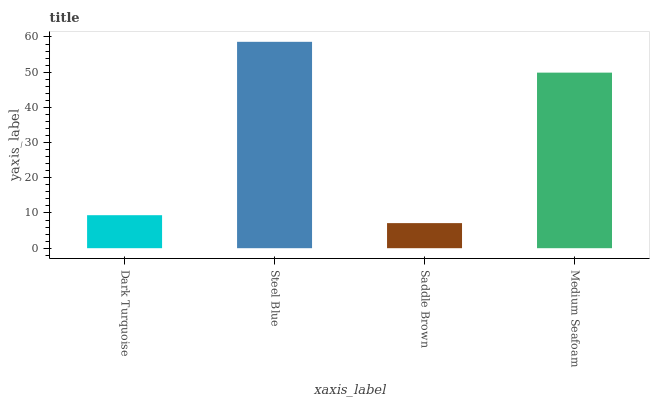Is Saddle Brown the minimum?
Answer yes or no. Yes. Is Steel Blue the maximum?
Answer yes or no. Yes. Is Steel Blue the minimum?
Answer yes or no. No. Is Saddle Brown the maximum?
Answer yes or no. No. Is Steel Blue greater than Saddle Brown?
Answer yes or no. Yes. Is Saddle Brown less than Steel Blue?
Answer yes or no. Yes. Is Saddle Brown greater than Steel Blue?
Answer yes or no. No. Is Steel Blue less than Saddle Brown?
Answer yes or no. No. Is Medium Seafoam the high median?
Answer yes or no. Yes. Is Dark Turquoise the low median?
Answer yes or no. Yes. Is Saddle Brown the high median?
Answer yes or no. No. Is Saddle Brown the low median?
Answer yes or no. No. 